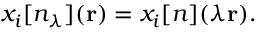<formula> <loc_0><loc_0><loc_500><loc_500>x _ { i } [ n _ { \lambda } ] ( r ) = x _ { i } [ n ] ( \lambda r ) .</formula> 